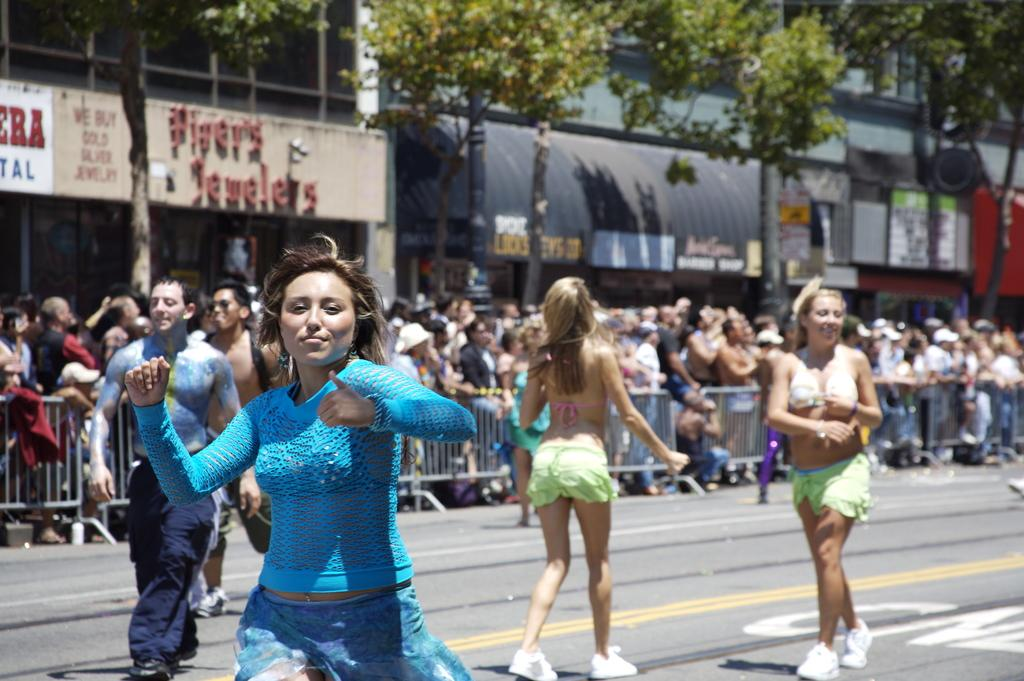What is happening on the road in the image? There are people on the road in the image. How would you describe the background of the image? The background is blurry, and there is a crowd, a fence, buildings, trees, and hoardings visible. Can you describe the setting of the image? The image is set on a road with a busy background. Is there a scarecrow involved in a fight in the image? No, there is no scarecrow or fight present in the image. 